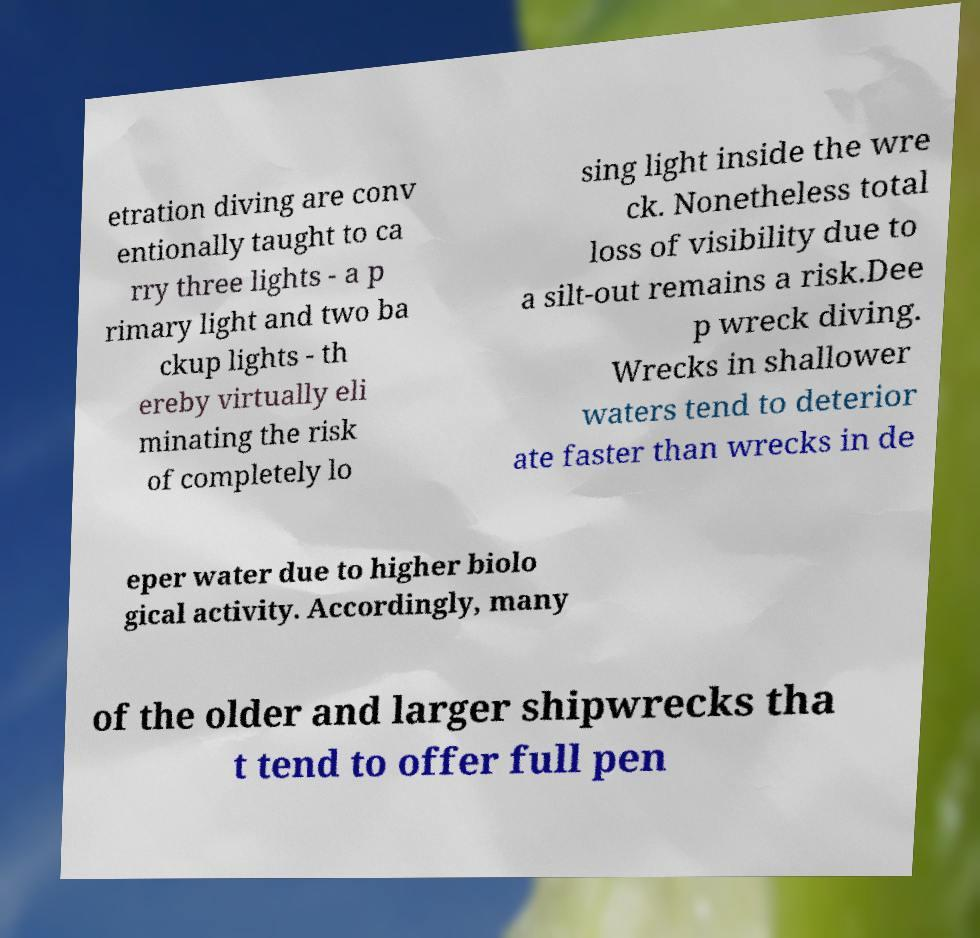Please identify and transcribe the text found in this image. etration diving are conv entionally taught to ca rry three lights - a p rimary light and two ba ckup lights - th ereby virtually eli minating the risk of completely lo sing light inside the wre ck. Nonetheless total loss of visibility due to a silt-out remains a risk.Dee p wreck diving. Wrecks in shallower waters tend to deterior ate faster than wrecks in de eper water due to higher biolo gical activity. Accordingly, many of the older and larger shipwrecks tha t tend to offer full pen 